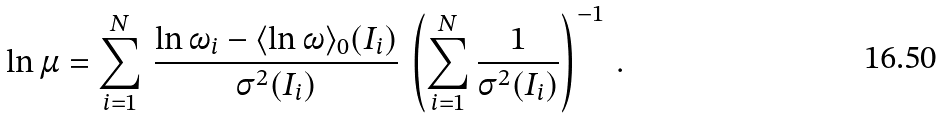<formula> <loc_0><loc_0><loc_500><loc_500>\ln \mu = \sum _ { i = 1 } ^ { N } \, \frac { \ln \omega _ { i } - \langle \ln \omega \rangle _ { 0 } ( I _ { i } ) } { \sigma ^ { 2 } ( I _ { i } ) } \, \left ( \sum _ { i = 1 } ^ { N } \frac { 1 } { \sigma ^ { 2 } ( I _ { i } ) } \right ) ^ { - 1 } \, .</formula> 